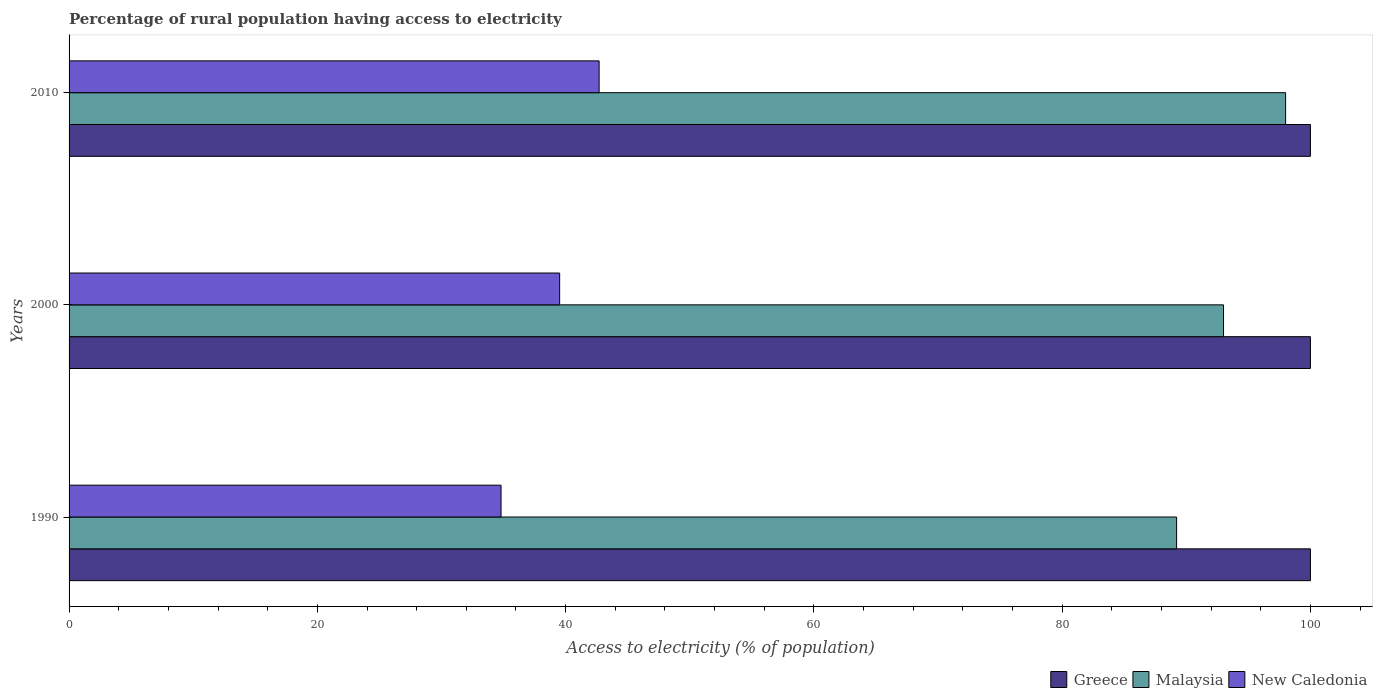How many different coloured bars are there?
Your response must be concise. 3. Are the number of bars per tick equal to the number of legend labels?
Provide a short and direct response. Yes. Are the number of bars on each tick of the Y-axis equal?
Offer a terse response. Yes. How many bars are there on the 1st tick from the bottom?
Make the answer very short. 3. What is the label of the 1st group of bars from the top?
Provide a succinct answer. 2010. What is the percentage of rural population having access to electricity in New Caledonia in 2000?
Keep it short and to the point. 39.52. Across all years, what is the maximum percentage of rural population having access to electricity in New Caledonia?
Ensure brevity in your answer.  42.7. Across all years, what is the minimum percentage of rural population having access to electricity in Greece?
Give a very brief answer. 100. In which year was the percentage of rural population having access to electricity in New Caledonia minimum?
Keep it short and to the point. 1990. What is the total percentage of rural population having access to electricity in New Caledonia in the graph?
Your answer should be very brief. 117.02. What is the difference between the percentage of rural population having access to electricity in New Caledonia in 1990 and that in 2000?
Ensure brevity in your answer.  -4.72. What is the difference between the percentage of rural population having access to electricity in Malaysia in 1990 and the percentage of rural population having access to electricity in Greece in 2010?
Your response must be concise. -10.78. What is the average percentage of rural population having access to electricity in Malaysia per year?
Give a very brief answer. 93.41. In the year 2010, what is the difference between the percentage of rural population having access to electricity in Greece and percentage of rural population having access to electricity in New Caledonia?
Your answer should be very brief. 57.3. What is the ratio of the percentage of rural population having access to electricity in Malaysia in 2000 to that in 2010?
Your answer should be compact. 0.95. Is the percentage of rural population having access to electricity in Greece in 2000 less than that in 2010?
Provide a succinct answer. No. What is the difference between the highest and the second highest percentage of rural population having access to electricity in New Caledonia?
Offer a very short reply. 3.18. What is the difference between the highest and the lowest percentage of rural population having access to electricity in New Caledonia?
Your response must be concise. 7.9. In how many years, is the percentage of rural population having access to electricity in Malaysia greater than the average percentage of rural population having access to electricity in Malaysia taken over all years?
Offer a terse response. 1. What does the 1st bar from the top in 2000 represents?
Provide a succinct answer. New Caledonia. What does the 2nd bar from the bottom in 1990 represents?
Offer a terse response. Malaysia. How many bars are there?
Your answer should be very brief. 9. Are all the bars in the graph horizontal?
Ensure brevity in your answer.  Yes. Does the graph contain any zero values?
Offer a very short reply. No. How many legend labels are there?
Provide a short and direct response. 3. How are the legend labels stacked?
Provide a succinct answer. Horizontal. What is the title of the graph?
Keep it short and to the point. Percentage of rural population having access to electricity. What is the label or title of the X-axis?
Your answer should be very brief. Access to electricity (% of population). What is the label or title of the Y-axis?
Give a very brief answer. Years. What is the Access to electricity (% of population) in Greece in 1990?
Ensure brevity in your answer.  100. What is the Access to electricity (% of population) in Malaysia in 1990?
Provide a short and direct response. 89.22. What is the Access to electricity (% of population) of New Caledonia in 1990?
Provide a short and direct response. 34.8. What is the Access to electricity (% of population) in Malaysia in 2000?
Offer a terse response. 93. What is the Access to electricity (% of population) in New Caledonia in 2000?
Ensure brevity in your answer.  39.52. What is the Access to electricity (% of population) of Greece in 2010?
Provide a succinct answer. 100. What is the Access to electricity (% of population) of Malaysia in 2010?
Ensure brevity in your answer.  98. What is the Access to electricity (% of population) of New Caledonia in 2010?
Your response must be concise. 42.7. Across all years, what is the maximum Access to electricity (% of population) in Malaysia?
Your answer should be compact. 98. Across all years, what is the maximum Access to electricity (% of population) in New Caledonia?
Your answer should be compact. 42.7. Across all years, what is the minimum Access to electricity (% of population) in Greece?
Provide a succinct answer. 100. Across all years, what is the minimum Access to electricity (% of population) of Malaysia?
Provide a succinct answer. 89.22. Across all years, what is the minimum Access to electricity (% of population) in New Caledonia?
Your answer should be very brief. 34.8. What is the total Access to electricity (% of population) of Greece in the graph?
Your answer should be compact. 300. What is the total Access to electricity (% of population) of Malaysia in the graph?
Your answer should be compact. 280.22. What is the total Access to electricity (% of population) in New Caledonia in the graph?
Your answer should be compact. 117.02. What is the difference between the Access to electricity (% of population) in Malaysia in 1990 and that in 2000?
Ensure brevity in your answer.  -3.78. What is the difference between the Access to electricity (% of population) of New Caledonia in 1990 and that in 2000?
Give a very brief answer. -4.72. What is the difference between the Access to electricity (% of population) of Greece in 1990 and that in 2010?
Offer a terse response. 0. What is the difference between the Access to electricity (% of population) of Malaysia in 1990 and that in 2010?
Your answer should be very brief. -8.78. What is the difference between the Access to electricity (% of population) in New Caledonia in 1990 and that in 2010?
Ensure brevity in your answer.  -7.9. What is the difference between the Access to electricity (% of population) in Greece in 2000 and that in 2010?
Offer a very short reply. 0. What is the difference between the Access to electricity (% of population) of Malaysia in 2000 and that in 2010?
Make the answer very short. -5. What is the difference between the Access to electricity (% of population) in New Caledonia in 2000 and that in 2010?
Your response must be concise. -3.18. What is the difference between the Access to electricity (% of population) of Greece in 1990 and the Access to electricity (% of population) of New Caledonia in 2000?
Your answer should be very brief. 60.48. What is the difference between the Access to electricity (% of population) in Malaysia in 1990 and the Access to electricity (% of population) in New Caledonia in 2000?
Ensure brevity in your answer.  49.7. What is the difference between the Access to electricity (% of population) of Greece in 1990 and the Access to electricity (% of population) of Malaysia in 2010?
Provide a succinct answer. 2. What is the difference between the Access to electricity (% of population) in Greece in 1990 and the Access to electricity (% of population) in New Caledonia in 2010?
Offer a terse response. 57.3. What is the difference between the Access to electricity (% of population) in Malaysia in 1990 and the Access to electricity (% of population) in New Caledonia in 2010?
Make the answer very short. 46.52. What is the difference between the Access to electricity (% of population) in Greece in 2000 and the Access to electricity (% of population) in Malaysia in 2010?
Keep it short and to the point. 2. What is the difference between the Access to electricity (% of population) in Greece in 2000 and the Access to electricity (% of population) in New Caledonia in 2010?
Provide a succinct answer. 57.3. What is the difference between the Access to electricity (% of population) of Malaysia in 2000 and the Access to electricity (% of population) of New Caledonia in 2010?
Your answer should be very brief. 50.3. What is the average Access to electricity (% of population) in Malaysia per year?
Make the answer very short. 93.41. What is the average Access to electricity (% of population) in New Caledonia per year?
Provide a short and direct response. 39.01. In the year 1990, what is the difference between the Access to electricity (% of population) of Greece and Access to electricity (% of population) of Malaysia?
Provide a short and direct response. 10.78. In the year 1990, what is the difference between the Access to electricity (% of population) in Greece and Access to electricity (% of population) in New Caledonia?
Provide a short and direct response. 65.2. In the year 1990, what is the difference between the Access to electricity (% of population) in Malaysia and Access to electricity (% of population) in New Caledonia?
Make the answer very short. 54.42. In the year 2000, what is the difference between the Access to electricity (% of population) of Greece and Access to electricity (% of population) of New Caledonia?
Make the answer very short. 60.48. In the year 2000, what is the difference between the Access to electricity (% of population) of Malaysia and Access to electricity (% of population) of New Caledonia?
Ensure brevity in your answer.  53.48. In the year 2010, what is the difference between the Access to electricity (% of population) in Greece and Access to electricity (% of population) in Malaysia?
Your answer should be very brief. 2. In the year 2010, what is the difference between the Access to electricity (% of population) in Greece and Access to electricity (% of population) in New Caledonia?
Your answer should be compact. 57.3. In the year 2010, what is the difference between the Access to electricity (% of population) in Malaysia and Access to electricity (% of population) in New Caledonia?
Your answer should be compact. 55.3. What is the ratio of the Access to electricity (% of population) in Malaysia in 1990 to that in 2000?
Your answer should be very brief. 0.96. What is the ratio of the Access to electricity (% of population) in New Caledonia in 1990 to that in 2000?
Offer a very short reply. 0.88. What is the ratio of the Access to electricity (% of population) in Greece in 1990 to that in 2010?
Provide a short and direct response. 1. What is the ratio of the Access to electricity (% of population) in Malaysia in 1990 to that in 2010?
Provide a succinct answer. 0.91. What is the ratio of the Access to electricity (% of population) of New Caledonia in 1990 to that in 2010?
Give a very brief answer. 0.81. What is the ratio of the Access to electricity (% of population) of Greece in 2000 to that in 2010?
Provide a short and direct response. 1. What is the ratio of the Access to electricity (% of population) in Malaysia in 2000 to that in 2010?
Your response must be concise. 0.95. What is the ratio of the Access to electricity (% of population) in New Caledonia in 2000 to that in 2010?
Your response must be concise. 0.93. What is the difference between the highest and the second highest Access to electricity (% of population) of Malaysia?
Offer a very short reply. 5. What is the difference between the highest and the second highest Access to electricity (% of population) in New Caledonia?
Make the answer very short. 3.18. What is the difference between the highest and the lowest Access to electricity (% of population) in Malaysia?
Your answer should be very brief. 8.78. What is the difference between the highest and the lowest Access to electricity (% of population) of New Caledonia?
Offer a very short reply. 7.9. 